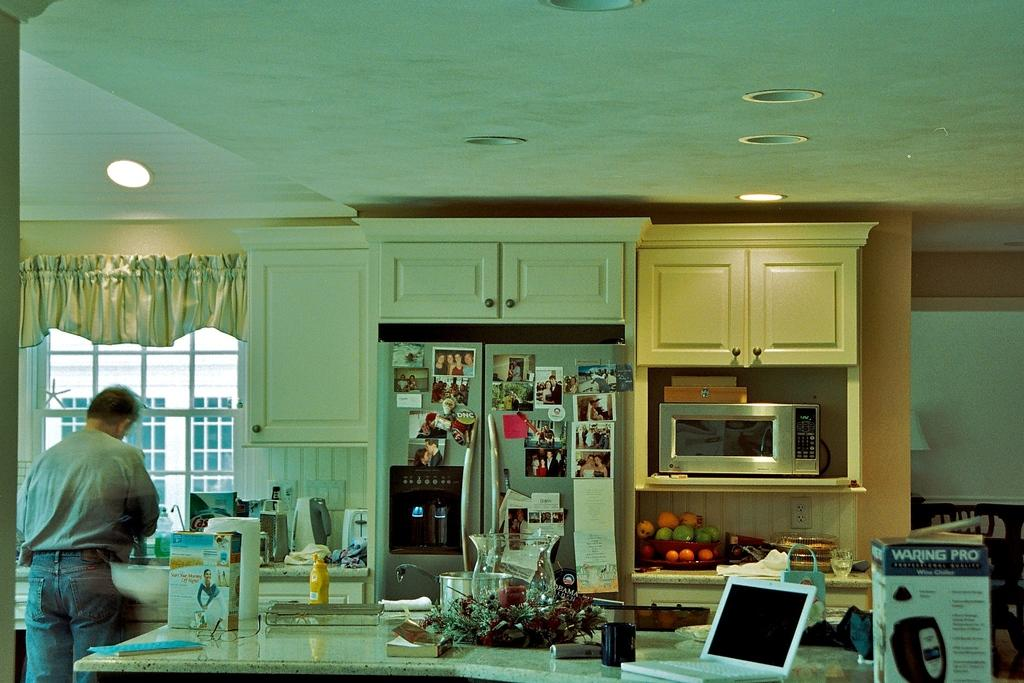<image>
Describe the image concisely. A kitchen counter with a box for Waring Pro. 